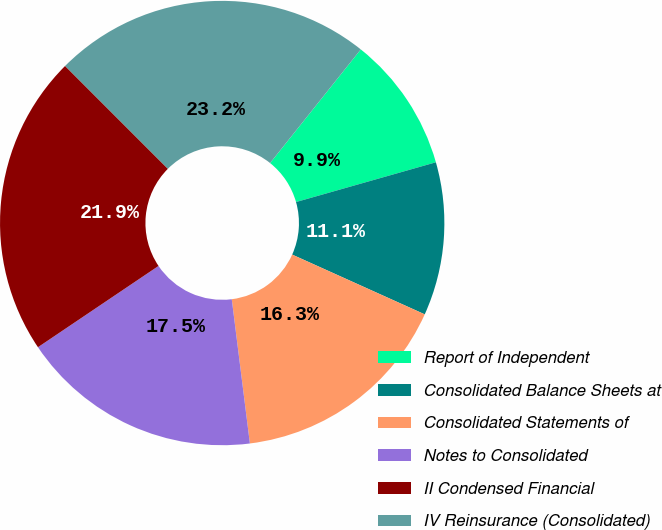Convert chart. <chart><loc_0><loc_0><loc_500><loc_500><pie_chart><fcel>Report of Independent<fcel>Consolidated Balance Sheets at<fcel>Consolidated Statements of<fcel>Notes to Consolidated<fcel>II Condensed Financial<fcel>IV Reinsurance (Consolidated)<nl><fcel>9.87%<fcel>11.15%<fcel>16.27%<fcel>17.55%<fcel>21.94%<fcel>23.22%<nl></chart> 